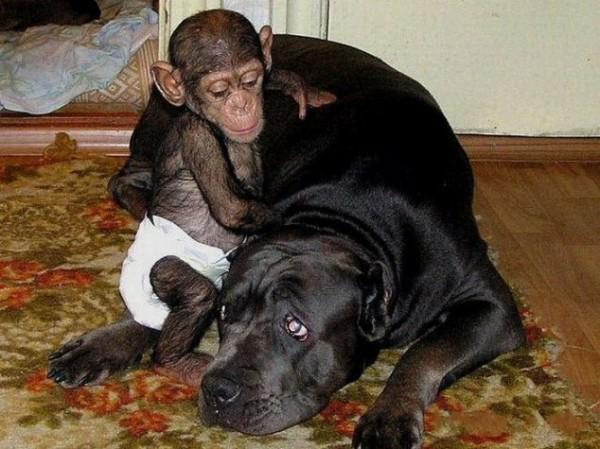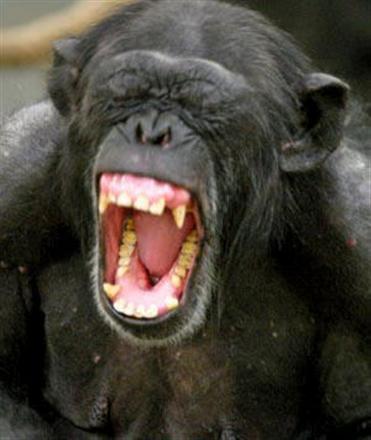The first image is the image on the left, the second image is the image on the right. Considering the images on both sides, is "An ape is holding a baby white tiger." valid? Answer yes or no. No. The first image is the image on the left, the second image is the image on the right. Examine the images to the left and right. Is the description "there is a person in the image on the right" accurate? Answer yes or no. No. 